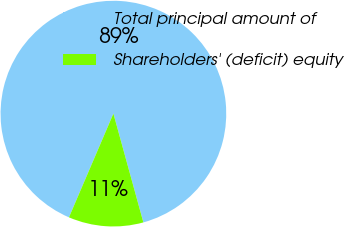Convert chart. <chart><loc_0><loc_0><loc_500><loc_500><pie_chart><fcel>Total principal amount of<fcel>Shareholders' (deficit) equity<nl><fcel>89.28%<fcel>10.72%<nl></chart> 